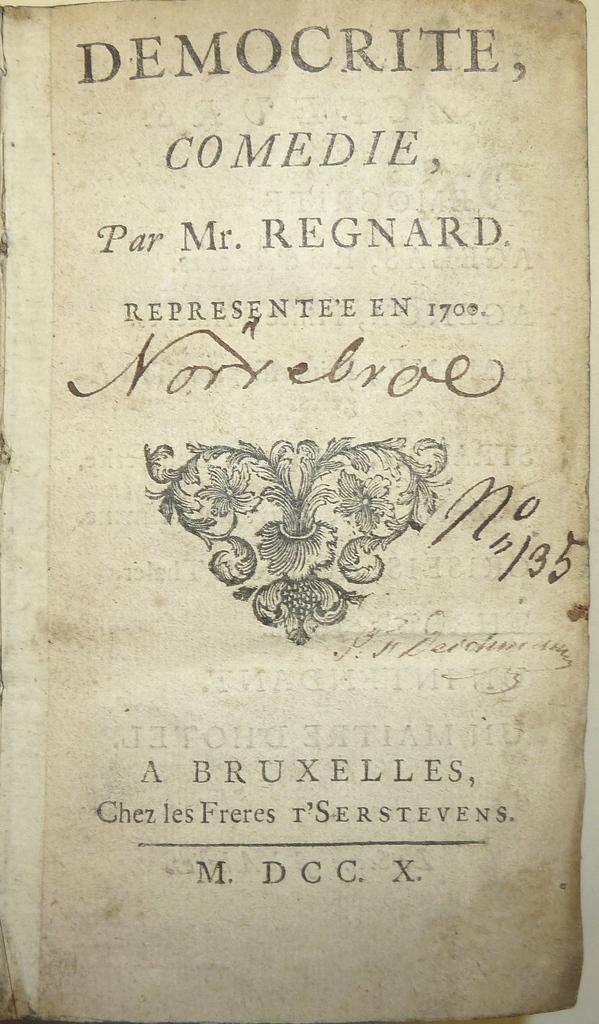What genre is this book?
Offer a very short reply. Comedie. What year was this book written?
Give a very brief answer. 1700. 